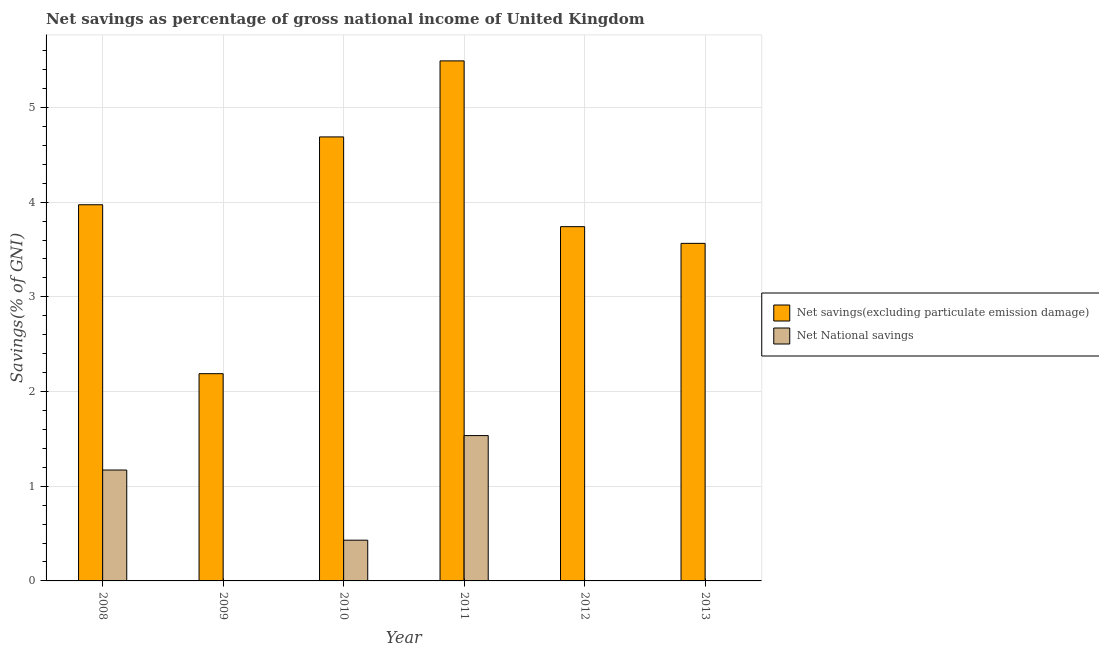Are the number of bars per tick equal to the number of legend labels?
Your answer should be very brief. No. In how many cases, is the number of bars for a given year not equal to the number of legend labels?
Ensure brevity in your answer.  3. Across all years, what is the maximum net national savings?
Keep it short and to the point. 1.53. Across all years, what is the minimum net savings(excluding particulate emission damage)?
Your answer should be very brief. 2.19. What is the total net national savings in the graph?
Offer a very short reply. 3.14. What is the difference between the net savings(excluding particulate emission damage) in 2008 and that in 2010?
Your answer should be compact. -0.72. What is the difference between the net national savings in 2011 and the net savings(excluding particulate emission damage) in 2013?
Make the answer very short. 1.53. What is the average net savings(excluding particulate emission damage) per year?
Give a very brief answer. 3.94. In how many years, is the net savings(excluding particulate emission damage) greater than 2 %?
Give a very brief answer. 6. What is the ratio of the net savings(excluding particulate emission damage) in 2010 to that in 2011?
Your answer should be compact. 0.85. What is the difference between the highest and the second highest net national savings?
Offer a very short reply. 0.36. What is the difference between the highest and the lowest net national savings?
Your answer should be very brief. 1.53. Is the sum of the net national savings in 2008 and 2010 greater than the maximum net savings(excluding particulate emission damage) across all years?
Offer a very short reply. Yes. How many bars are there?
Your answer should be compact. 9. Does the graph contain any zero values?
Offer a very short reply. Yes. Does the graph contain grids?
Your answer should be compact. Yes. Where does the legend appear in the graph?
Give a very brief answer. Center right. How many legend labels are there?
Offer a very short reply. 2. What is the title of the graph?
Your answer should be very brief. Net savings as percentage of gross national income of United Kingdom. Does "Investment" appear as one of the legend labels in the graph?
Your answer should be compact. No. What is the label or title of the X-axis?
Ensure brevity in your answer.  Year. What is the label or title of the Y-axis?
Keep it short and to the point. Savings(% of GNI). What is the Savings(% of GNI) of Net savings(excluding particulate emission damage) in 2008?
Give a very brief answer. 3.97. What is the Savings(% of GNI) of Net National savings in 2008?
Make the answer very short. 1.17. What is the Savings(% of GNI) of Net savings(excluding particulate emission damage) in 2009?
Make the answer very short. 2.19. What is the Savings(% of GNI) of Net savings(excluding particulate emission damage) in 2010?
Offer a terse response. 4.69. What is the Savings(% of GNI) of Net National savings in 2010?
Provide a short and direct response. 0.43. What is the Savings(% of GNI) in Net savings(excluding particulate emission damage) in 2011?
Your response must be concise. 5.49. What is the Savings(% of GNI) of Net National savings in 2011?
Ensure brevity in your answer.  1.53. What is the Savings(% of GNI) in Net savings(excluding particulate emission damage) in 2012?
Keep it short and to the point. 3.74. What is the Savings(% of GNI) of Net savings(excluding particulate emission damage) in 2013?
Make the answer very short. 3.57. What is the Savings(% of GNI) in Net National savings in 2013?
Provide a short and direct response. 0. Across all years, what is the maximum Savings(% of GNI) of Net savings(excluding particulate emission damage)?
Offer a terse response. 5.49. Across all years, what is the maximum Savings(% of GNI) in Net National savings?
Keep it short and to the point. 1.53. Across all years, what is the minimum Savings(% of GNI) in Net savings(excluding particulate emission damage)?
Ensure brevity in your answer.  2.19. Across all years, what is the minimum Savings(% of GNI) in Net National savings?
Your answer should be very brief. 0. What is the total Savings(% of GNI) of Net savings(excluding particulate emission damage) in the graph?
Your answer should be very brief. 23.65. What is the total Savings(% of GNI) of Net National savings in the graph?
Give a very brief answer. 3.14. What is the difference between the Savings(% of GNI) of Net savings(excluding particulate emission damage) in 2008 and that in 2009?
Your answer should be compact. 1.78. What is the difference between the Savings(% of GNI) of Net savings(excluding particulate emission damage) in 2008 and that in 2010?
Make the answer very short. -0.72. What is the difference between the Savings(% of GNI) of Net National savings in 2008 and that in 2010?
Your answer should be compact. 0.74. What is the difference between the Savings(% of GNI) of Net savings(excluding particulate emission damage) in 2008 and that in 2011?
Your response must be concise. -1.52. What is the difference between the Savings(% of GNI) of Net National savings in 2008 and that in 2011?
Your response must be concise. -0.36. What is the difference between the Savings(% of GNI) in Net savings(excluding particulate emission damage) in 2008 and that in 2012?
Make the answer very short. 0.23. What is the difference between the Savings(% of GNI) in Net savings(excluding particulate emission damage) in 2008 and that in 2013?
Your answer should be very brief. 0.41. What is the difference between the Savings(% of GNI) of Net savings(excluding particulate emission damage) in 2009 and that in 2010?
Keep it short and to the point. -2.5. What is the difference between the Savings(% of GNI) in Net savings(excluding particulate emission damage) in 2009 and that in 2011?
Provide a short and direct response. -3.3. What is the difference between the Savings(% of GNI) in Net savings(excluding particulate emission damage) in 2009 and that in 2012?
Your answer should be very brief. -1.55. What is the difference between the Savings(% of GNI) of Net savings(excluding particulate emission damage) in 2009 and that in 2013?
Your response must be concise. -1.38. What is the difference between the Savings(% of GNI) in Net savings(excluding particulate emission damage) in 2010 and that in 2011?
Give a very brief answer. -0.8. What is the difference between the Savings(% of GNI) in Net National savings in 2010 and that in 2011?
Provide a succinct answer. -1.1. What is the difference between the Savings(% of GNI) in Net savings(excluding particulate emission damage) in 2010 and that in 2012?
Keep it short and to the point. 0.95. What is the difference between the Savings(% of GNI) of Net savings(excluding particulate emission damage) in 2010 and that in 2013?
Provide a short and direct response. 1.12. What is the difference between the Savings(% of GNI) of Net savings(excluding particulate emission damage) in 2011 and that in 2012?
Ensure brevity in your answer.  1.75. What is the difference between the Savings(% of GNI) in Net savings(excluding particulate emission damage) in 2011 and that in 2013?
Provide a short and direct response. 1.93. What is the difference between the Savings(% of GNI) of Net savings(excluding particulate emission damage) in 2012 and that in 2013?
Offer a very short reply. 0.18. What is the difference between the Savings(% of GNI) of Net savings(excluding particulate emission damage) in 2008 and the Savings(% of GNI) of Net National savings in 2010?
Give a very brief answer. 3.54. What is the difference between the Savings(% of GNI) of Net savings(excluding particulate emission damage) in 2008 and the Savings(% of GNI) of Net National savings in 2011?
Offer a terse response. 2.44. What is the difference between the Savings(% of GNI) of Net savings(excluding particulate emission damage) in 2009 and the Savings(% of GNI) of Net National savings in 2010?
Give a very brief answer. 1.76. What is the difference between the Savings(% of GNI) in Net savings(excluding particulate emission damage) in 2009 and the Savings(% of GNI) in Net National savings in 2011?
Your answer should be compact. 0.65. What is the difference between the Savings(% of GNI) of Net savings(excluding particulate emission damage) in 2010 and the Savings(% of GNI) of Net National savings in 2011?
Provide a short and direct response. 3.15. What is the average Savings(% of GNI) in Net savings(excluding particulate emission damage) per year?
Give a very brief answer. 3.94. What is the average Savings(% of GNI) of Net National savings per year?
Keep it short and to the point. 0.52. In the year 2008, what is the difference between the Savings(% of GNI) in Net savings(excluding particulate emission damage) and Savings(% of GNI) in Net National savings?
Keep it short and to the point. 2.8. In the year 2010, what is the difference between the Savings(% of GNI) in Net savings(excluding particulate emission damage) and Savings(% of GNI) in Net National savings?
Ensure brevity in your answer.  4.26. In the year 2011, what is the difference between the Savings(% of GNI) of Net savings(excluding particulate emission damage) and Savings(% of GNI) of Net National savings?
Provide a succinct answer. 3.96. What is the ratio of the Savings(% of GNI) in Net savings(excluding particulate emission damage) in 2008 to that in 2009?
Ensure brevity in your answer.  1.82. What is the ratio of the Savings(% of GNI) in Net savings(excluding particulate emission damage) in 2008 to that in 2010?
Make the answer very short. 0.85. What is the ratio of the Savings(% of GNI) of Net National savings in 2008 to that in 2010?
Provide a short and direct response. 2.72. What is the ratio of the Savings(% of GNI) in Net savings(excluding particulate emission damage) in 2008 to that in 2011?
Ensure brevity in your answer.  0.72. What is the ratio of the Savings(% of GNI) of Net National savings in 2008 to that in 2011?
Offer a terse response. 0.76. What is the ratio of the Savings(% of GNI) of Net savings(excluding particulate emission damage) in 2008 to that in 2012?
Give a very brief answer. 1.06. What is the ratio of the Savings(% of GNI) of Net savings(excluding particulate emission damage) in 2008 to that in 2013?
Offer a terse response. 1.11. What is the ratio of the Savings(% of GNI) in Net savings(excluding particulate emission damage) in 2009 to that in 2010?
Your answer should be compact. 0.47. What is the ratio of the Savings(% of GNI) in Net savings(excluding particulate emission damage) in 2009 to that in 2011?
Offer a very short reply. 0.4. What is the ratio of the Savings(% of GNI) in Net savings(excluding particulate emission damage) in 2009 to that in 2012?
Provide a short and direct response. 0.58. What is the ratio of the Savings(% of GNI) in Net savings(excluding particulate emission damage) in 2009 to that in 2013?
Provide a succinct answer. 0.61. What is the ratio of the Savings(% of GNI) in Net savings(excluding particulate emission damage) in 2010 to that in 2011?
Your answer should be compact. 0.85. What is the ratio of the Savings(% of GNI) in Net National savings in 2010 to that in 2011?
Make the answer very short. 0.28. What is the ratio of the Savings(% of GNI) of Net savings(excluding particulate emission damage) in 2010 to that in 2012?
Provide a short and direct response. 1.25. What is the ratio of the Savings(% of GNI) in Net savings(excluding particulate emission damage) in 2010 to that in 2013?
Keep it short and to the point. 1.32. What is the ratio of the Savings(% of GNI) in Net savings(excluding particulate emission damage) in 2011 to that in 2012?
Give a very brief answer. 1.47. What is the ratio of the Savings(% of GNI) in Net savings(excluding particulate emission damage) in 2011 to that in 2013?
Provide a succinct answer. 1.54. What is the ratio of the Savings(% of GNI) of Net savings(excluding particulate emission damage) in 2012 to that in 2013?
Provide a succinct answer. 1.05. What is the difference between the highest and the second highest Savings(% of GNI) of Net savings(excluding particulate emission damage)?
Ensure brevity in your answer.  0.8. What is the difference between the highest and the second highest Savings(% of GNI) of Net National savings?
Ensure brevity in your answer.  0.36. What is the difference between the highest and the lowest Savings(% of GNI) of Net savings(excluding particulate emission damage)?
Keep it short and to the point. 3.3. What is the difference between the highest and the lowest Savings(% of GNI) of Net National savings?
Offer a very short reply. 1.53. 